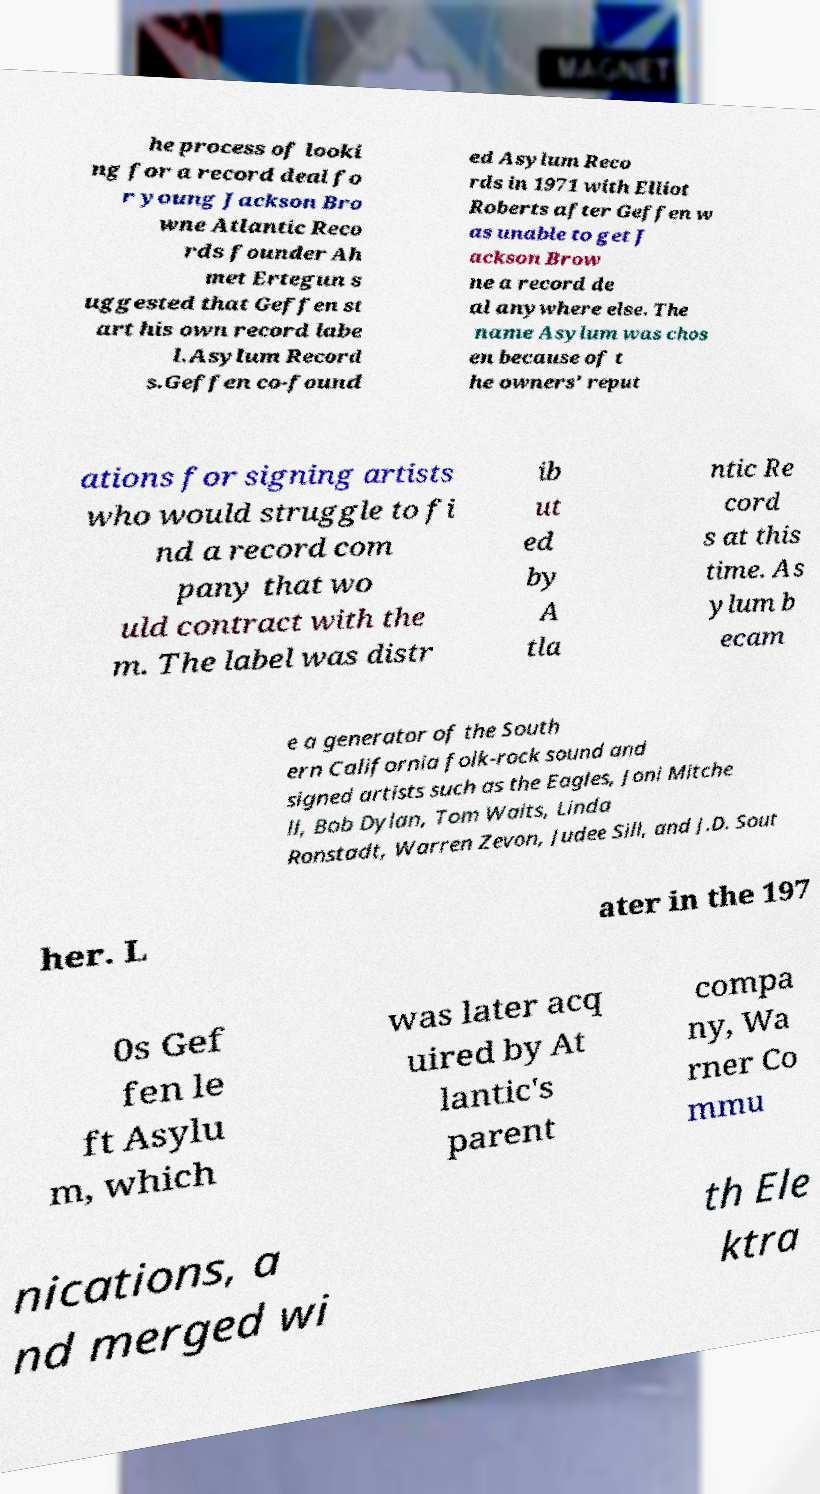Can you read and provide the text displayed in the image?This photo seems to have some interesting text. Can you extract and type it out for me? he process of looki ng for a record deal fo r young Jackson Bro wne Atlantic Reco rds founder Ah met Ertegun s uggested that Geffen st art his own record labe l.Asylum Record s.Geffen co-found ed Asylum Reco rds in 1971 with Elliot Roberts after Geffen w as unable to get J ackson Brow ne a record de al anywhere else. The name Asylum was chos en because of t he owners' reput ations for signing artists who would struggle to fi nd a record com pany that wo uld contract with the m. The label was distr ib ut ed by A tla ntic Re cord s at this time. As ylum b ecam e a generator of the South ern California folk-rock sound and signed artists such as the Eagles, Joni Mitche ll, Bob Dylan, Tom Waits, Linda Ronstadt, Warren Zevon, Judee Sill, and J.D. Sout her. L ater in the 197 0s Gef fen le ft Asylu m, which was later acq uired by At lantic's parent compa ny, Wa rner Co mmu nications, a nd merged wi th Ele ktra 